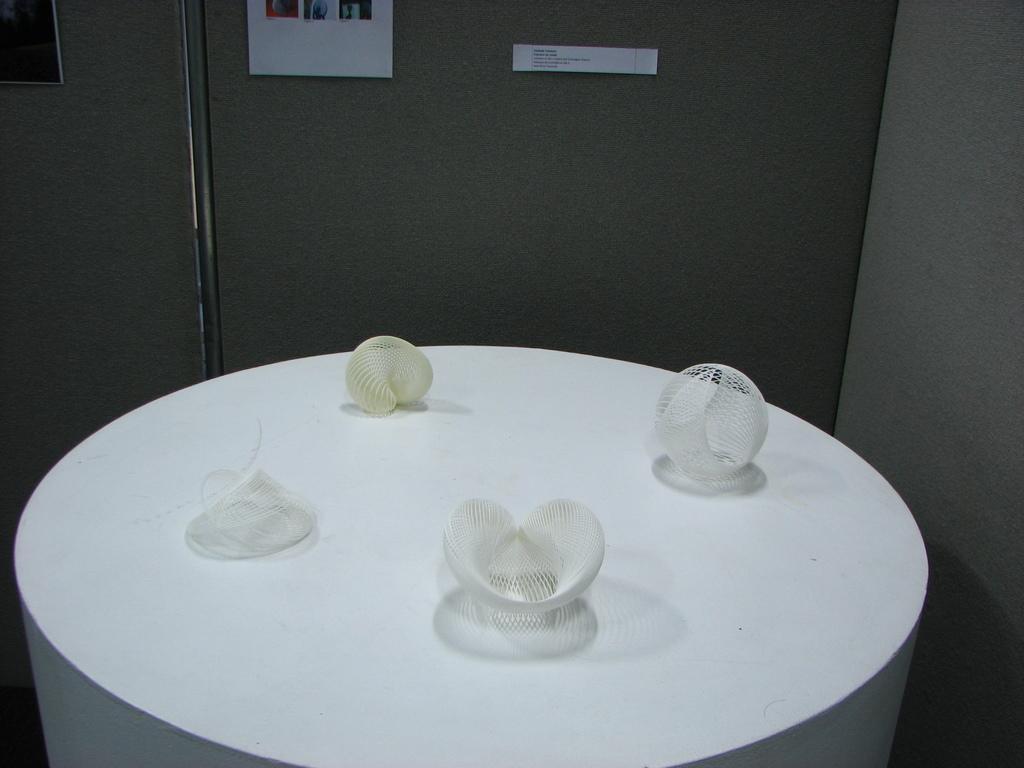In one or two sentences, can you explain what this image depicts? In the image there is a white table and on the table there are four different objects are kept and there is a wall in the right side of the table. 